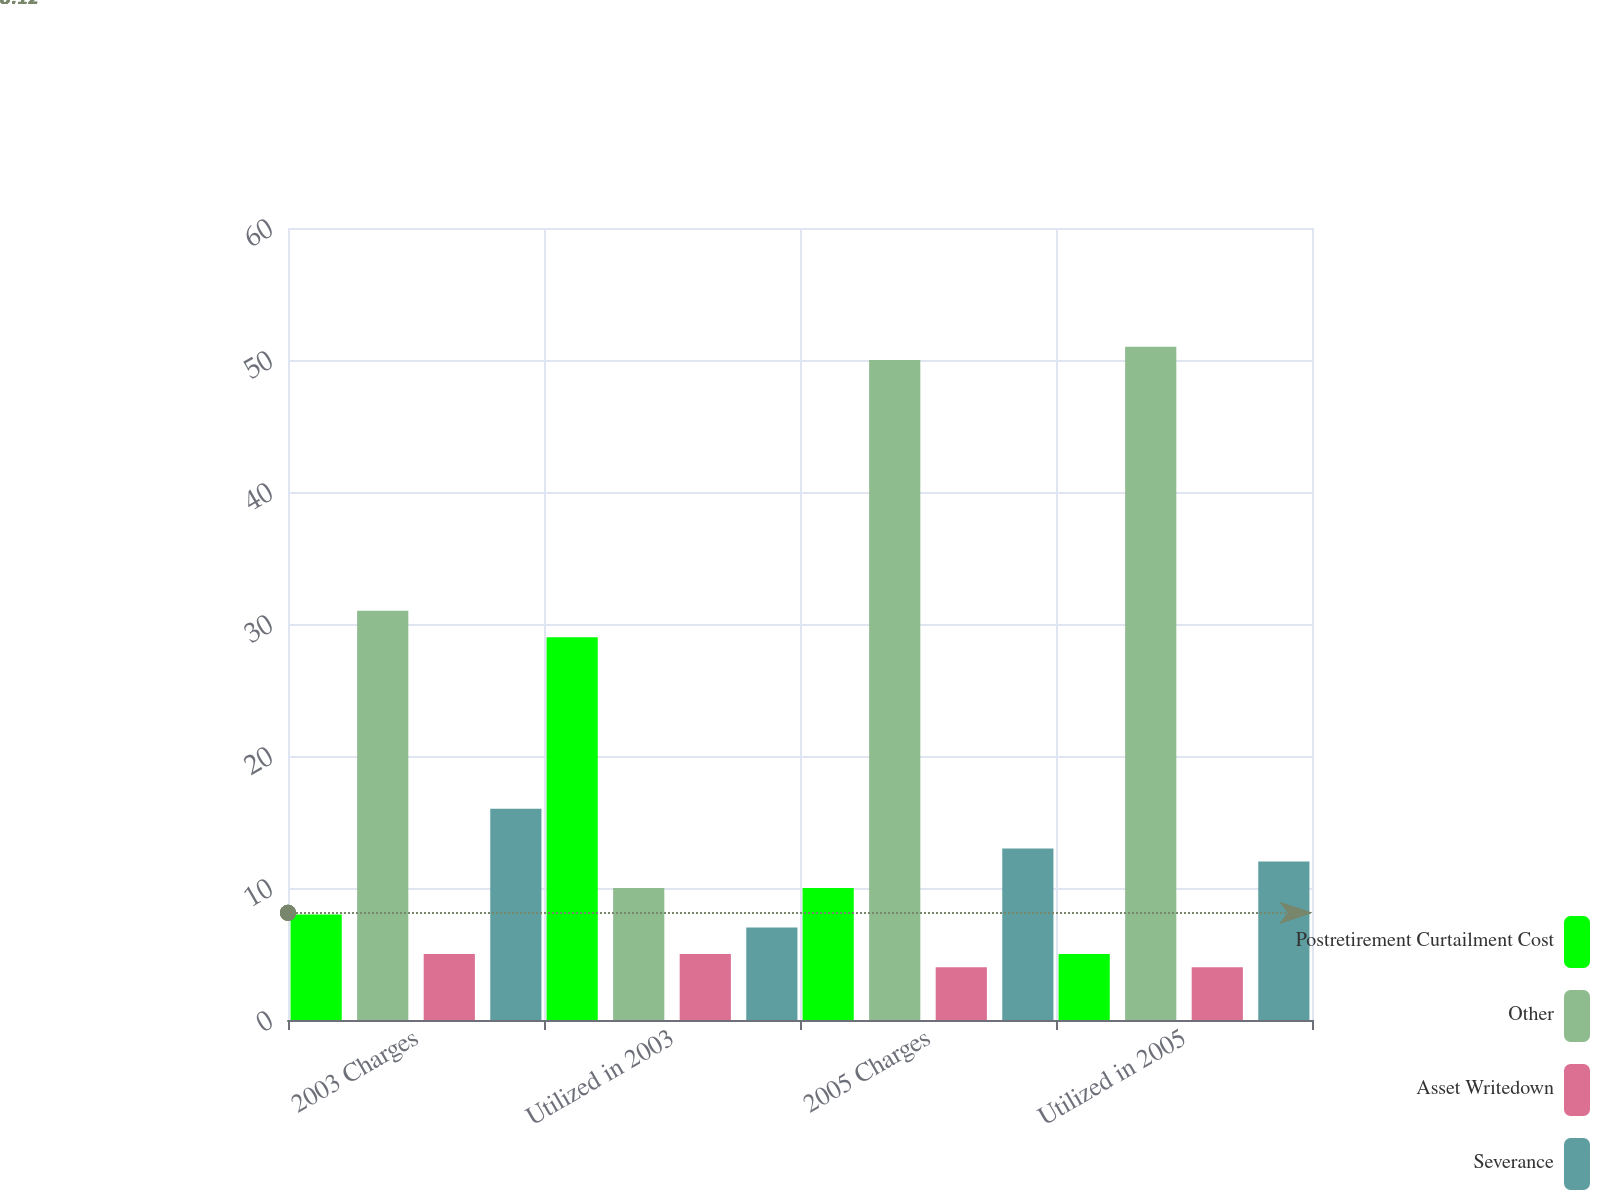Convert chart to OTSL. <chart><loc_0><loc_0><loc_500><loc_500><stacked_bar_chart><ecel><fcel>2003 Charges<fcel>Utilized in 2003<fcel>2005 Charges<fcel>Utilized in 2005<nl><fcel>Postretirement Curtailment Cost<fcel>8<fcel>29<fcel>10<fcel>5<nl><fcel>Other<fcel>31<fcel>10<fcel>50<fcel>51<nl><fcel>Asset Writedown<fcel>5<fcel>5<fcel>4<fcel>4<nl><fcel>Severance<fcel>16<fcel>7<fcel>13<fcel>12<nl></chart> 